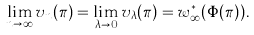Convert formula to latex. <formula><loc_0><loc_0><loc_500><loc_500>\lim _ { n \to \infty } v _ { n } ( \pi ) = \lim _ { \lambda \to 0 } v _ { \lambda } ( \pi ) = w ^ { * } _ { \infty } ( \Phi ( \pi ) ) .</formula> 